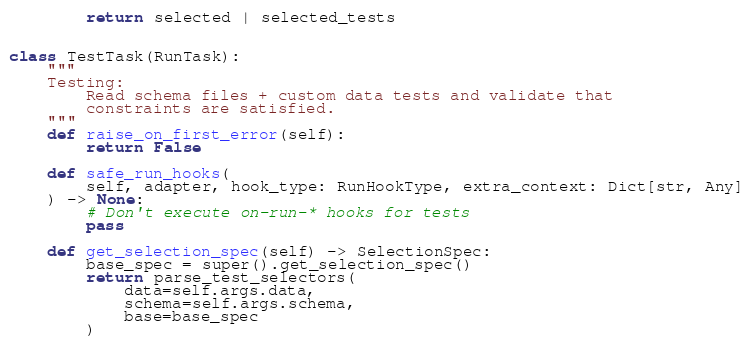Convert code to text. <code><loc_0><loc_0><loc_500><loc_500><_Python_>
        return selected | selected_tests


class TestTask(RunTask):
    """
    Testing:
        Read schema files + custom data tests and validate that
        constraints are satisfied.
    """
    def raise_on_first_error(self):
        return False

    def safe_run_hooks(
        self, adapter, hook_type: RunHookType, extra_context: Dict[str, Any]
    ) -> None:
        # Don't execute on-run-* hooks for tests
        pass

    def get_selection_spec(self) -> SelectionSpec:
        base_spec = super().get_selection_spec()
        return parse_test_selectors(
            data=self.args.data,
            schema=self.args.schema,
            base=base_spec
        )
</code> 